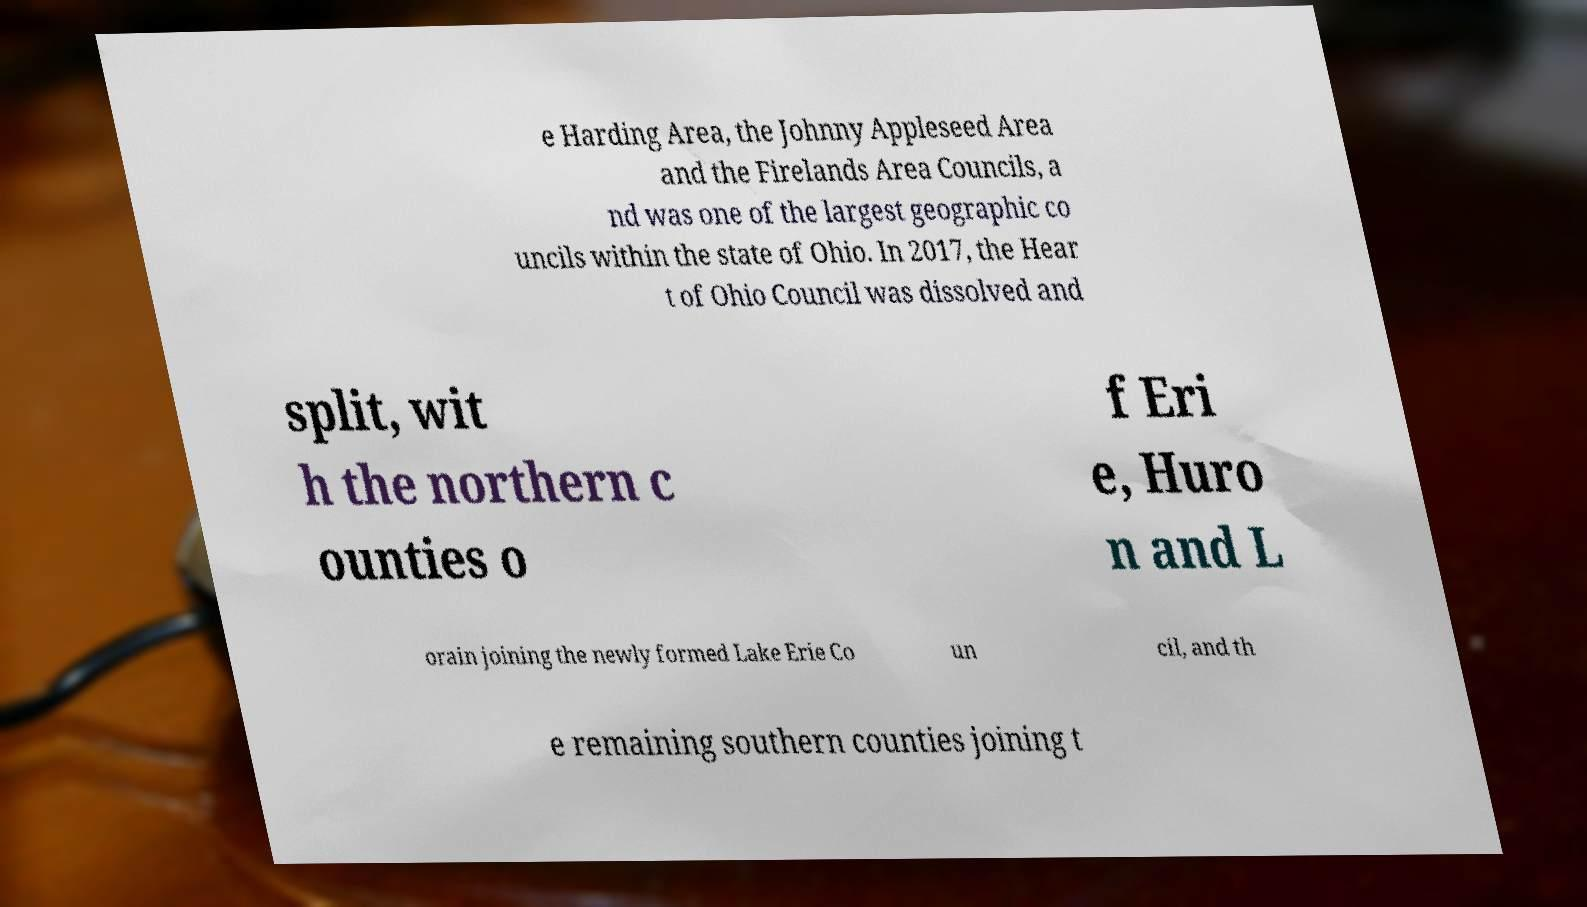Please identify and transcribe the text found in this image. e Harding Area, the Johnny Appleseed Area and the Firelands Area Councils, a nd was one of the largest geographic co uncils within the state of Ohio. In 2017, the Hear t of Ohio Council was dissolved and split, wit h the northern c ounties o f Eri e, Huro n and L orain joining the newly formed Lake Erie Co un cil, and th e remaining southern counties joining t 